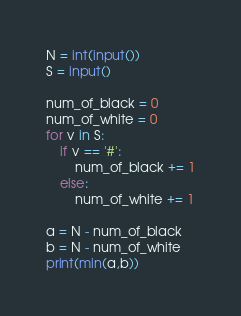<code> <loc_0><loc_0><loc_500><loc_500><_Python_>N = int(input())
S = input()

num_of_black = 0
num_of_white = 0
for v in S:
    if v == '#':
        num_of_black += 1
    else:
        num_of_white += 1

a = N - num_of_black
b = N - num_of_white
print(min(a,b))</code> 